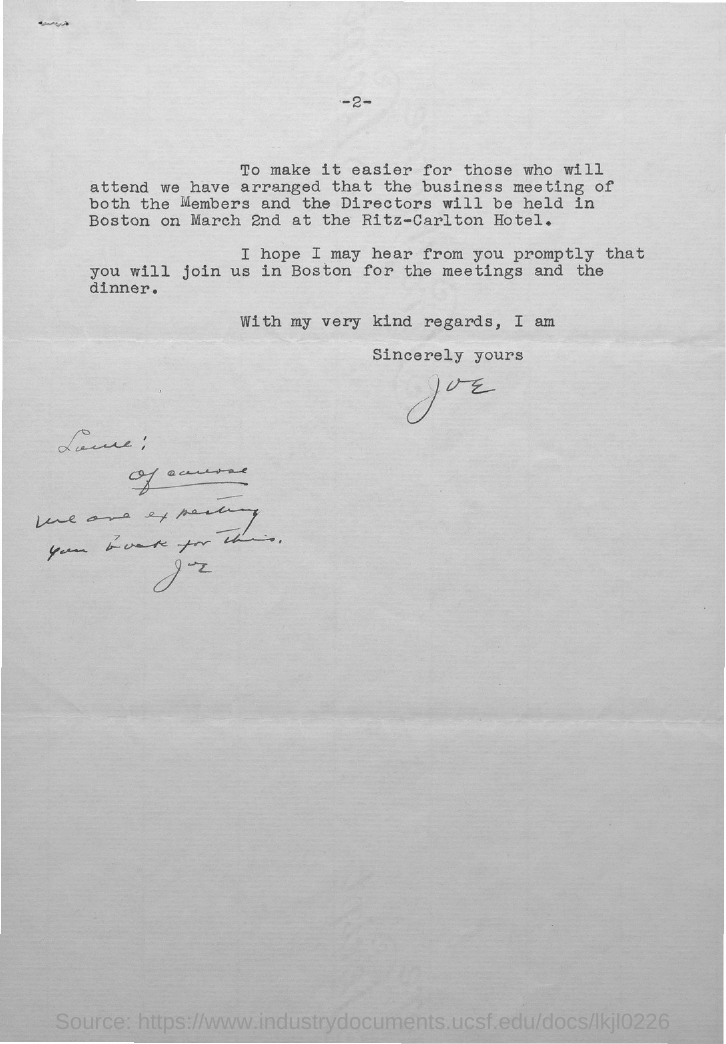Give some essential details in this illustration. The page number mentioned in this document is 2.. The sender of this letter is Joe. 